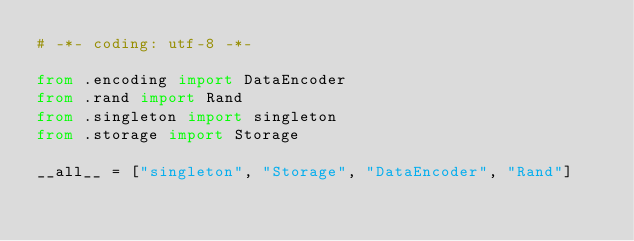Convert code to text. <code><loc_0><loc_0><loc_500><loc_500><_Python_># -*- coding: utf-8 -*-

from .encoding import DataEncoder
from .rand import Rand
from .singleton import singleton
from .storage import Storage

__all__ = ["singleton", "Storage", "DataEncoder", "Rand"]
</code> 